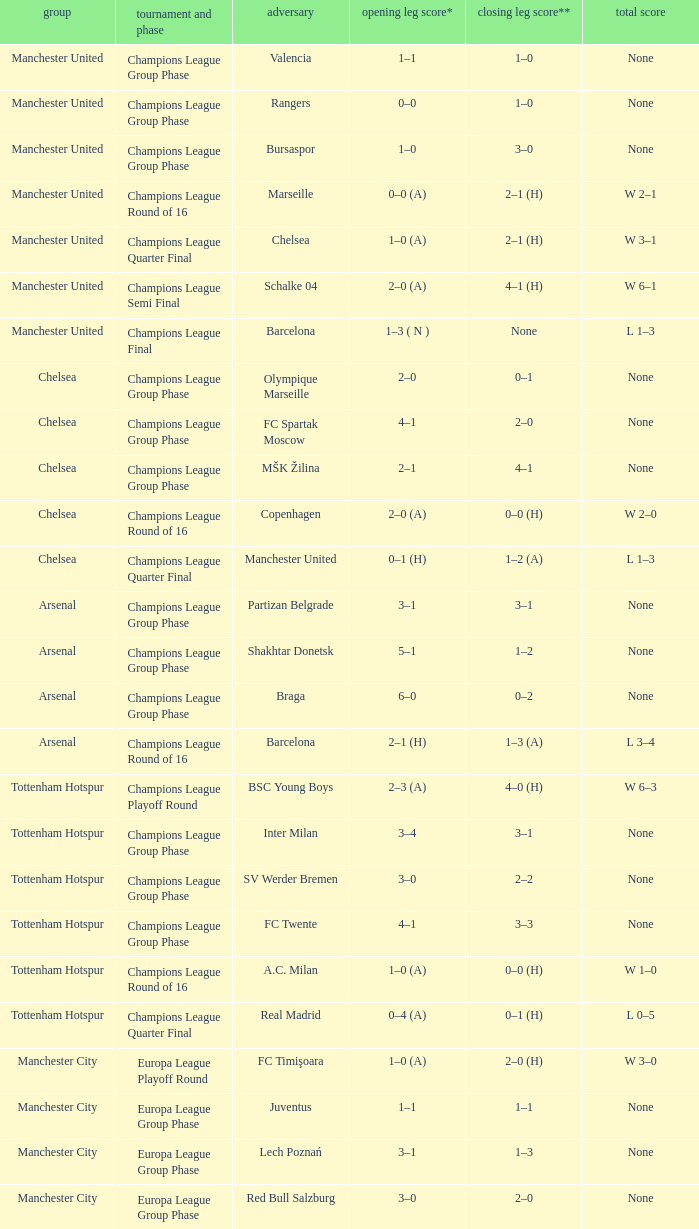How many goals did each one of the teams score in the first leg of the match between Liverpool and Trabzonspor? 1–0 (H). 